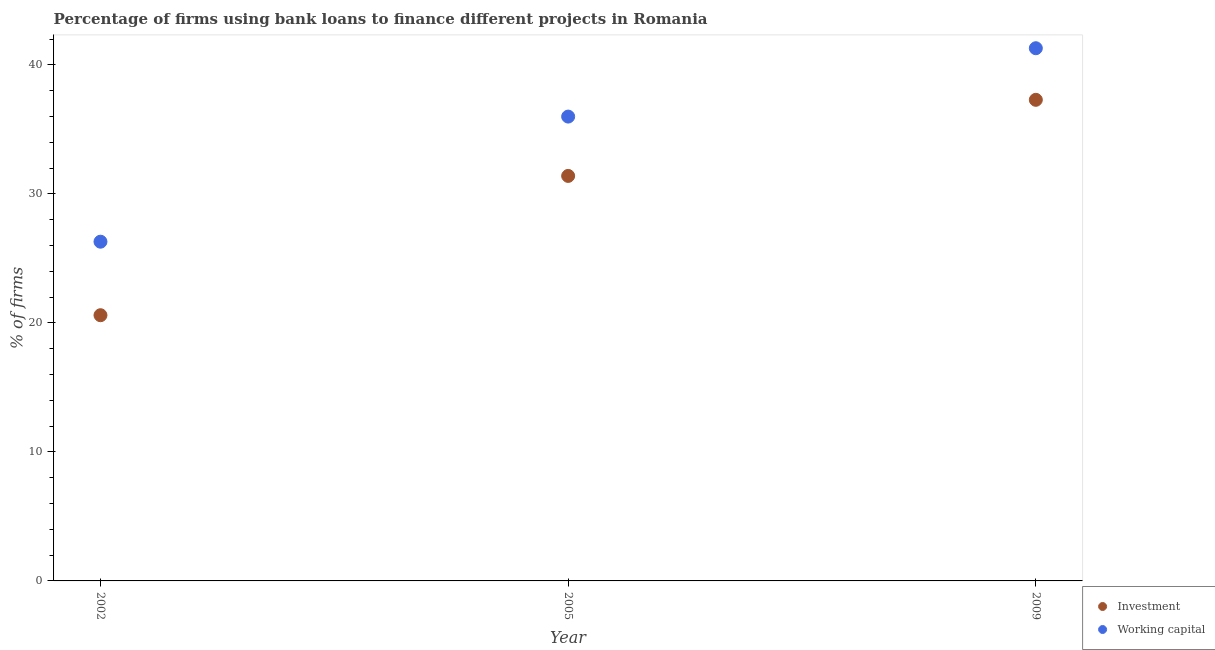How many different coloured dotlines are there?
Keep it short and to the point. 2. What is the percentage of firms using banks to finance working capital in 2005?
Give a very brief answer. 36. Across all years, what is the maximum percentage of firms using banks to finance working capital?
Make the answer very short. 41.3. Across all years, what is the minimum percentage of firms using banks to finance working capital?
Your answer should be compact. 26.3. What is the total percentage of firms using banks to finance working capital in the graph?
Provide a short and direct response. 103.6. What is the difference between the percentage of firms using banks to finance investment in 2002 and that in 2005?
Your answer should be compact. -10.8. What is the difference between the percentage of firms using banks to finance investment in 2009 and the percentage of firms using banks to finance working capital in 2005?
Give a very brief answer. 1.3. What is the average percentage of firms using banks to finance working capital per year?
Give a very brief answer. 34.53. What is the ratio of the percentage of firms using banks to finance investment in 2002 to that in 2005?
Provide a short and direct response. 0.66. Is the percentage of firms using banks to finance working capital in 2002 less than that in 2005?
Offer a terse response. Yes. What is the difference between the highest and the second highest percentage of firms using banks to finance working capital?
Your response must be concise. 5.3. What is the difference between the highest and the lowest percentage of firms using banks to finance working capital?
Make the answer very short. 15. In how many years, is the percentage of firms using banks to finance investment greater than the average percentage of firms using banks to finance investment taken over all years?
Your answer should be compact. 2. Is the sum of the percentage of firms using banks to finance investment in 2005 and 2009 greater than the maximum percentage of firms using banks to finance working capital across all years?
Keep it short and to the point. Yes. Is the percentage of firms using banks to finance working capital strictly greater than the percentage of firms using banks to finance investment over the years?
Your response must be concise. Yes. How many dotlines are there?
Keep it short and to the point. 2. What is the difference between two consecutive major ticks on the Y-axis?
Your answer should be compact. 10. Does the graph contain grids?
Offer a terse response. No. How many legend labels are there?
Your answer should be very brief. 2. What is the title of the graph?
Ensure brevity in your answer.  Percentage of firms using bank loans to finance different projects in Romania. Does "From Government" appear as one of the legend labels in the graph?
Your answer should be very brief. No. What is the label or title of the Y-axis?
Keep it short and to the point. % of firms. What is the % of firms in Investment in 2002?
Offer a very short reply. 20.6. What is the % of firms in Working capital in 2002?
Your response must be concise. 26.3. What is the % of firms in Investment in 2005?
Your response must be concise. 31.4. What is the % of firms in Working capital in 2005?
Your answer should be compact. 36. What is the % of firms of Investment in 2009?
Your answer should be very brief. 37.3. What is the % of firms of Working capital in 2009?
Offer a terse response. 41.3. Across all years, what is the maximum % of firms of Investment?
Provide a succinct answer. 37.3. Across all years, what is the maximum % of firms of Working capital?
Offer a very short reply. 41.3. Across all years, what is the minimum % of firms in Investment?
Give a very brief answer. 20.6. Across all years, what is the minimum % of firms in Working capital?
Your response must be concise. 26.3. What is the total % of firms in Investment in the graph?
Offer a very short reply. 89.3. What is the total % of firms in Working capital in the graph?
Keep it short and to the point. 103.6. What is the difference between the % of firms of Working capital in 2002 and that in 2005?
Provide a succinct answer. -9.7. What is the difference between the % of firms of Investment in 2002 and that in 2009?
Your answer should be very brief. -16.7. What is the difference between the % of firms of Working capital in 2002 and that in 2009?
Your response must be concise. -15. What is the difference between the % of firms in Working capital in 2005 and that in 2009?
Your answer should be very brief. -5.3. What is the difference between the % of firms of Investment in 2002 and the % of firms of Working capital in 2005?
Your answer should be compact. -15.4. What is the difference between the % of firms of Investment in 2002 and the % of firms of Working capital in 2009?
Your response must be concise. -20.7. What is the difference between the % of firms of Investment in 2005 and the % of firms of Working capital in 2009?
Your response must be concise. -9.9. What is the average % of firms of Investment per year?
Make the answer very short. 29.77. What is the average % of firms in Working capital per year?
Provide a succinct answer. 34.53. In the year 2002, what is the difference between the % of firms in Investment and % of firms in Working capital?
Give a very brief answer. -5.7. In the year 2005, what is the difference between the % of firms of Investment and % of firms of Working capital?
Ensure brevity in your answer.  -4.6. What is the ratio of the % of firms in Investment in 2002 to that in 2005?
Keep it short and to the point. 0.66. What is the ratio of the % of firms in Working capital in 2002 to that in 2005?
Provide a succinct answer. 0.73. What is the ratio of the % of firms in Investment in 2002 to that in 2009?
Provide a succinct answer. 0.55. What is the ratio of the % of firms of Working capital in 2002 to that in 2009?
Offer a terse response. 0.64. What is the ratio of the % of firms in Investment in 2005 to that in 2009?
Keep it short and to the point. 0.84. What is the ratio of the % of firms in Working capital in 2005 to that in 2009?
Keep it short and to the point. 0.87. 